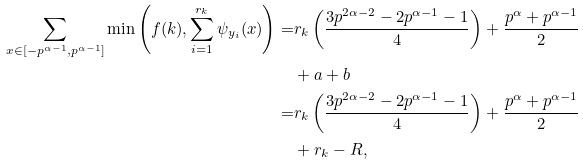<formula> <loc_0><loc_0><loc_500><loc_500>\sum _ { x \in [ - p ^ { \alpha - 1 } , p ^ { \alpha - 1 } ] } \min \left ( f ( k ) , \sum _ { i = 1 } ^ { r _ { k } } \psi _ { y _ { i } } ( x ) \right ) = & r _ { k } \left ( \frac { 3 p ^ { 2 \alpha - 2 } - 2 p ^ { \alpha - 1 } - 1 } { 4 } \right ) + \frac { p ^ { \alpha } + p ^ { \alpha - 1 } } { 2 } \\ & + a + b \\ = & r _ { k } \left ( \frac { 3 p ^ { 2 \alpha - 2 } - 2 p ^ { \alpha - 1 } - 1 } { 4 } \right ) + \frac { p ^ { \alpha } + p ^ { \alpha - 1 } } { 2 } \\ & + r _ { k } - R ,</formula> 